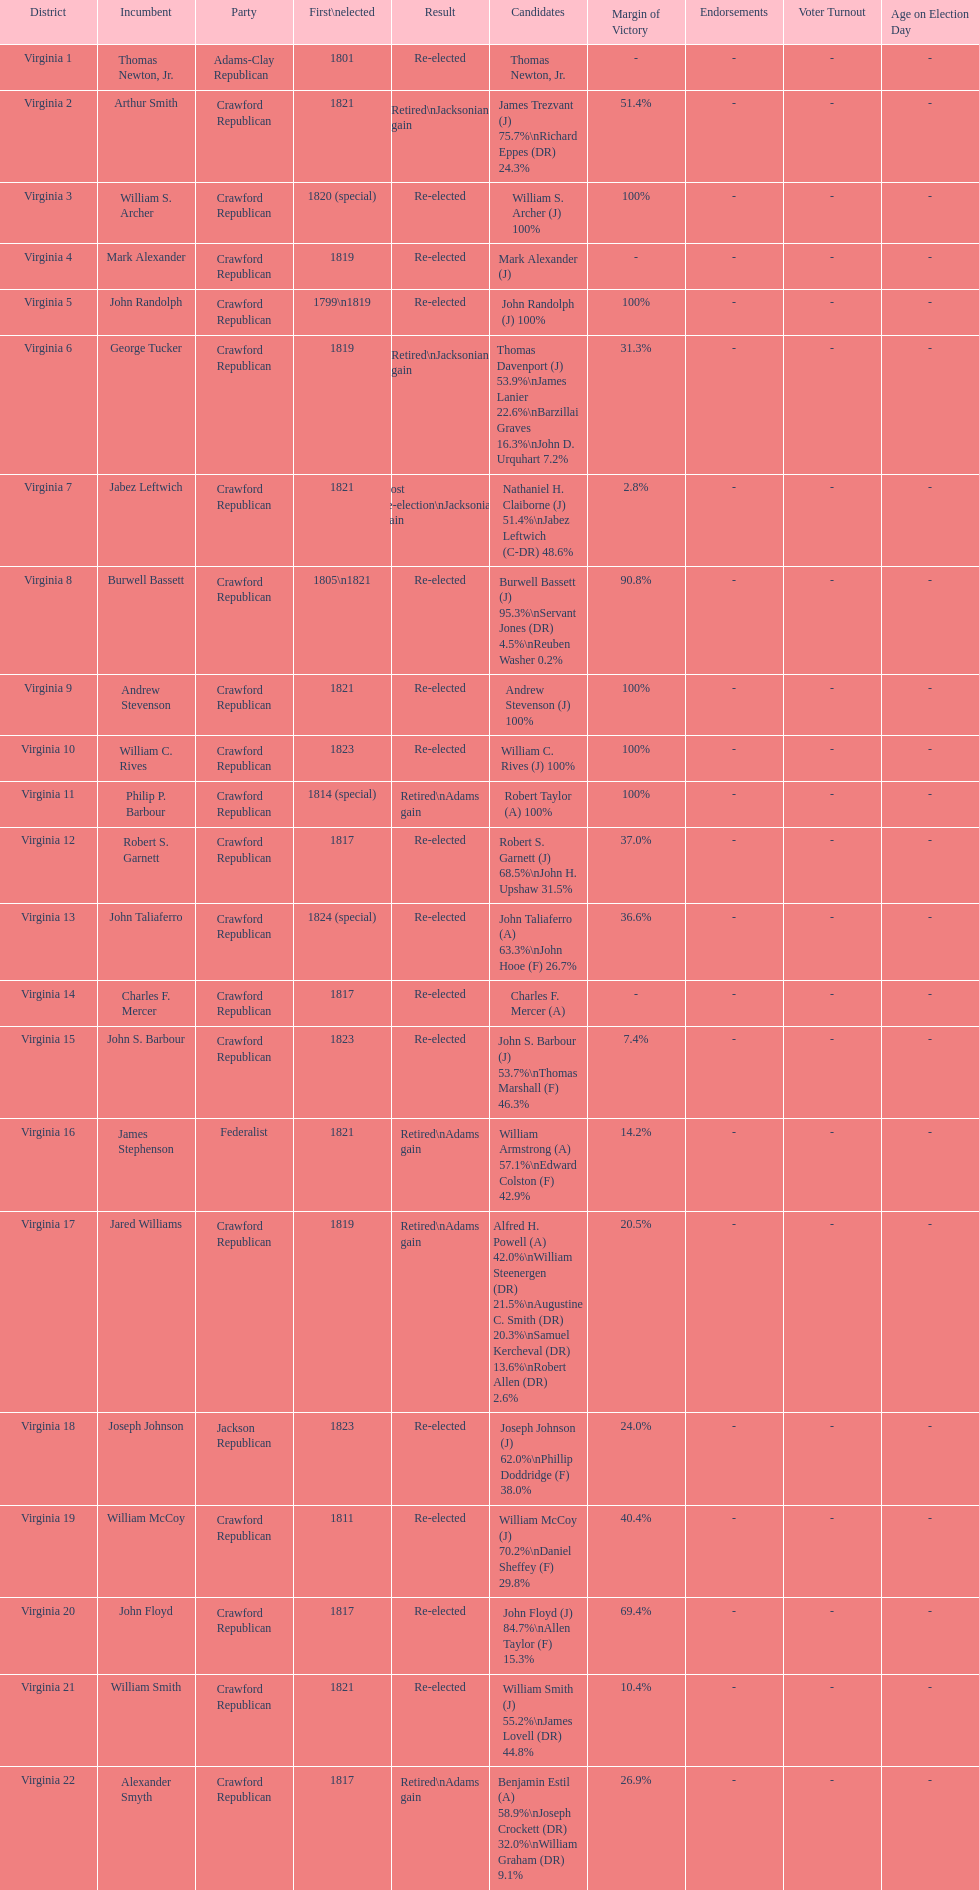Name the only candidate that was first elected in 1811. William McCoy. 